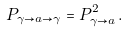Convert formula to latex. <formula><loc_0><loc_0><loc_500><loc_500>P _ { \gamma \to a \to \gamma } = P ^ { 2 } _ { \gamma \to a } \, .</formula> 